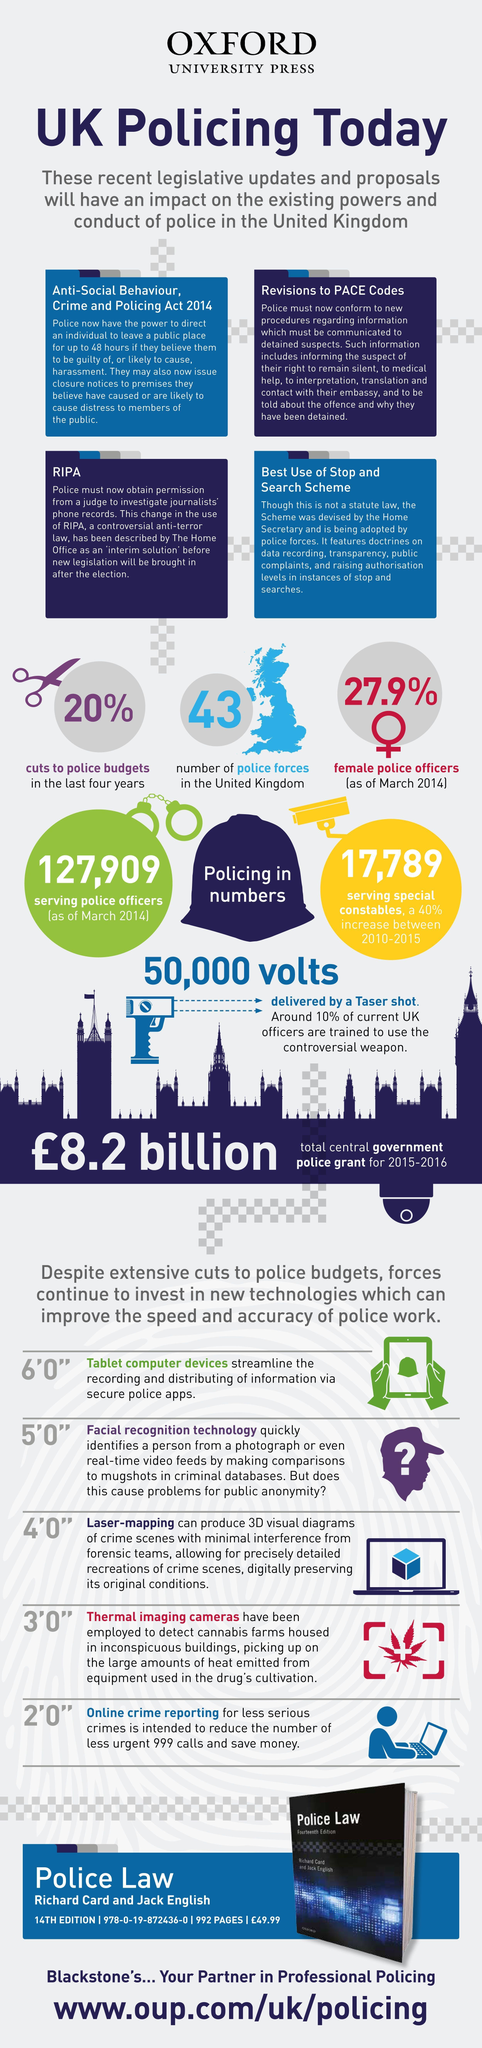Point out several critical features in this image. In the United Kingdom, approximately 90% of police officers are not trained to use Taser shots. The Taser is the primary weapon used by the United Kingdom Police force. The strength of the police force in the UK is 43... In the UK, it was reported that only 27.9% of police officers are women, which is a significant difference from the proportion of women in the general population. There are currently 127,909 police officers serving in the United Kingdom. 